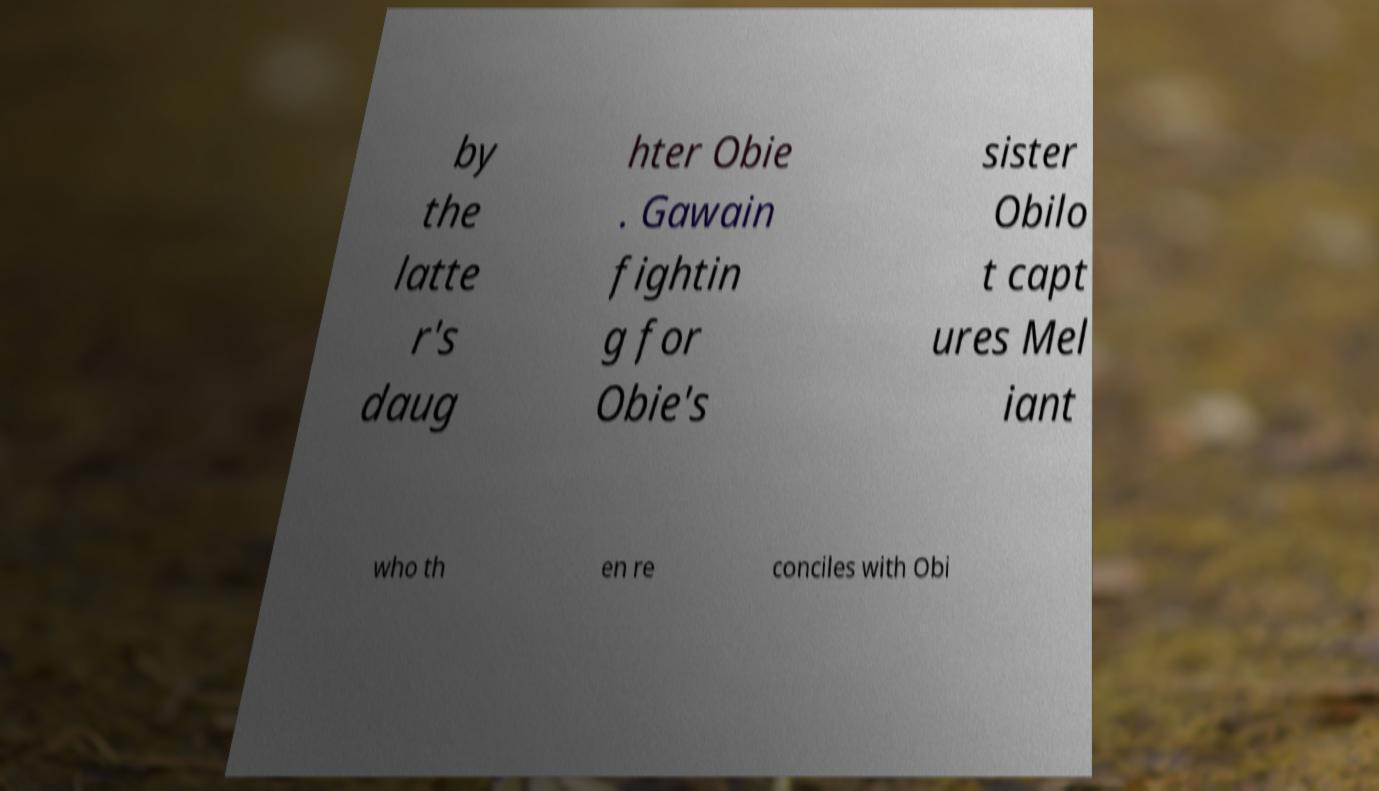Could you assist in decoding the text presented in this image and type it out clearly? by the latte r's daug hter Obie . Gawain fightin g for Obie's sister Obilo t capt ures Mel iant who th en re conciles with Obi 